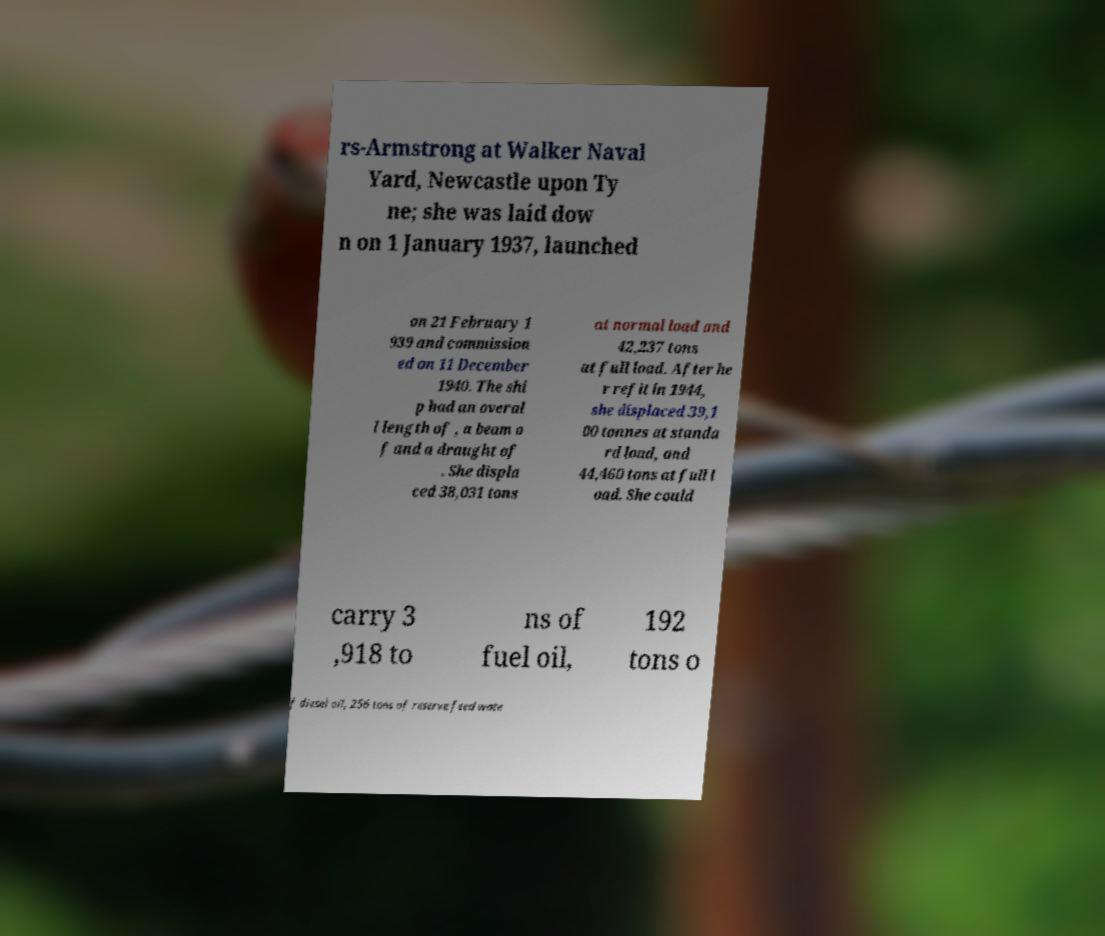Can you read and provide the text displayed in the image?This photo seems to have some interesting text. Can you extract and type it out for me? rs-Armstrong at Walker Naval Yard, Newcastle upon Ty ne; she was laid dow n on 1 January 1937, launched on 21 February 1 939 and commission ed on 11 December 1940. The shi p had an overal l length of , a beam o f and a draught of . She displa ced 38,031 tons at normal load and 42,237 tons at full load. After he r refit in 1944, she displaced 39,1 00 tonnes at standa rd load, and 44,460 tons at full l oad. She could carry 3 ,918 to ns of fuel oil, 192 tons o f diesel oil, 256 tons of reserve feed wate 